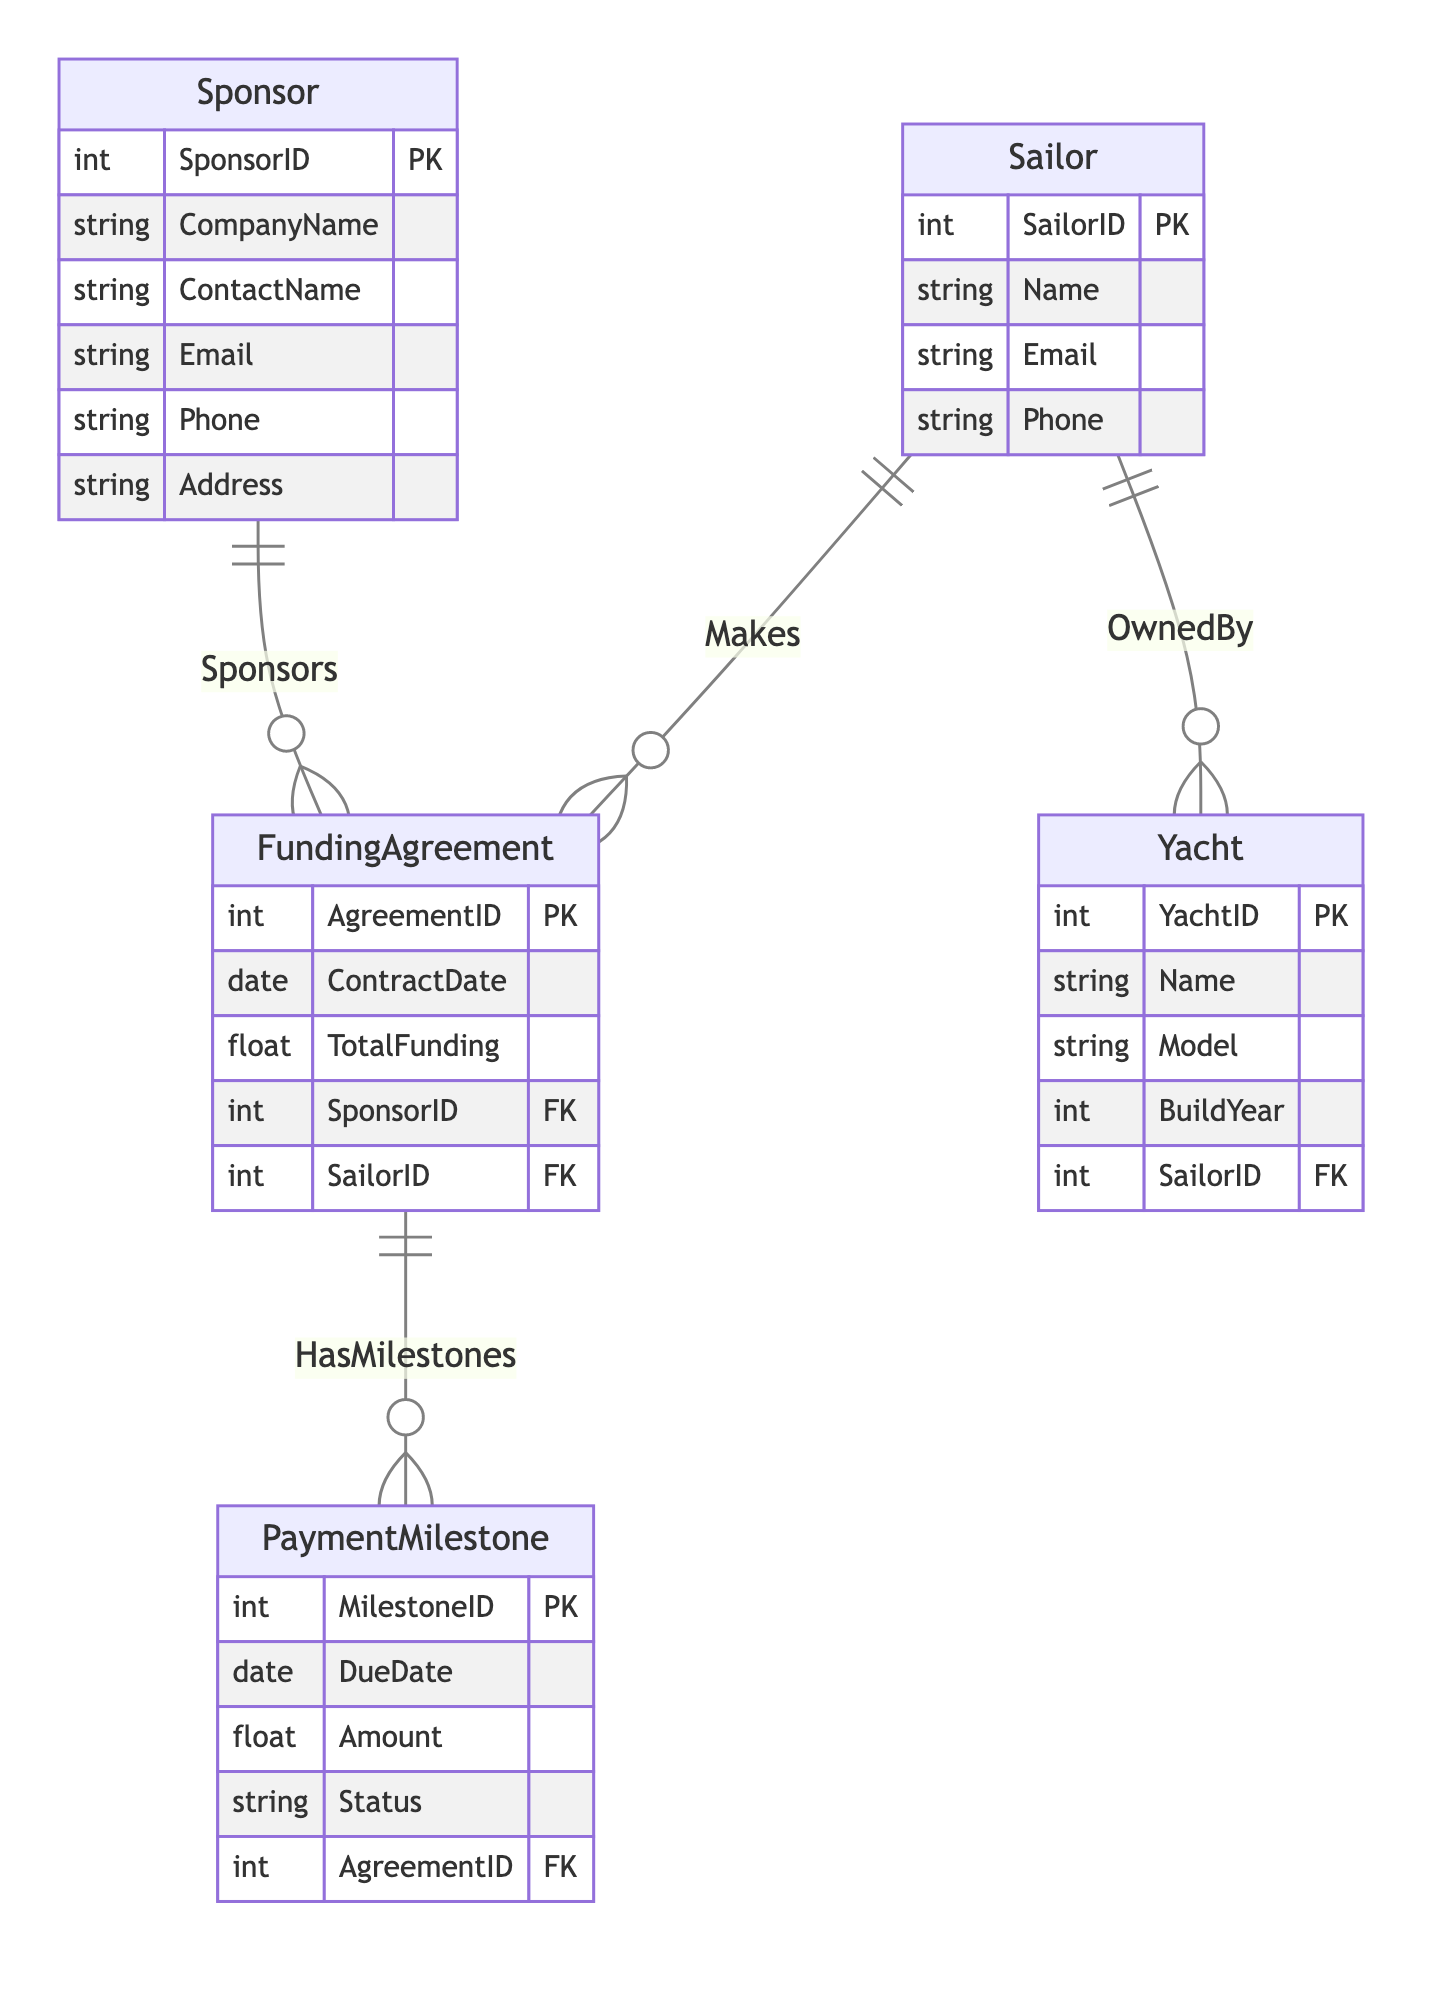What is the primary key of the Sailor entity? The primary key in the Sailor entity is SailorID, as indicated by the notation "PK" next to it. This key uniquely identifies each sailor within the database.
Answer: SailorID How many payment milestones can a funding agreement have? A funding agreement can have many payment milestones as indicated by the "1 to many" relationship between FundingAgreement and PaymentMilestone, meaning there can be multiple milestones corresponding to one agreement.
Answer: Many How many entities are there in total? There are five entities listed in the diagram: Sailor, Sponsor, Yacht, FundingAgreement, and PaymentMilestone. Adding these up gives a total of five entities.
Answer: Five Which entity has the attribute "TotalFunding"? The attribute "TotalFunding" belongs to the FundingAgreement entity, as it is listed explicitly under this entity's attributes in the diagram.
Answer: FundingAgreement What type of relationship exists between Sailor and Yacht? The relationship between Sailor and Yacht is "1 to many," meaning one sailor can own multiple yachts but each yacht is owned by only one sailor.
Answer: 1 to many How many payment milestones does a sailor have? A sailor can have multiple payment milestones through their funding agreements, as indicated by the relationship diagrams. However, to answer precisely, we must refer to the data which is not provided here. Thus, the number cannot be determined from just the diagram.
Answer: Cannot be determined Which entity is connected to the PaymentMilestone entity? The PaymentMilestone entity is connected to the FundingAgreement entity, indicating that each milestone is related to a specific funding agreement. This connection is part of the "HasMilestones" relationship.
Answer: FundingAgreement What does the status attribute in the PaymentMilestone represent? The status attribute in the PaymentMilestone entity likely represents the current status of the payment related to the milestone (e.g., completed, pending), which provides insight into the payment progress tied to the funding agreement.
Answer: Current status of payment How is the Sponsor connected to the FundingAgreement? The Sponsor is connected to the FundingAgreement through the "Sponsors" relationship, which signifies that a single sponsor can fund multiple agreements, thus showing a one-to-many relationship.
Answer: 1 to many 